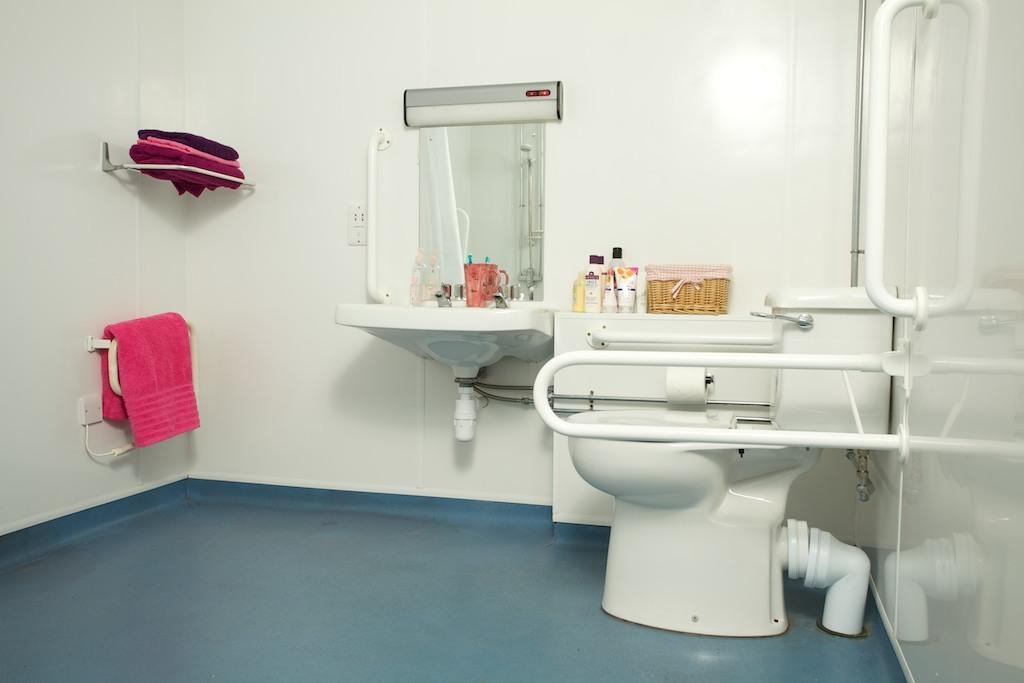Could you give a brief overview of what you see in this image? In the picture we can see a washroom with a toilet seat, beside it we can see a white color desk on it we can see some sanitize bottles and creams and beside it we can see a sink which is white in color and on it we can see a stand with brushed in it and to the wall we can see a mirror and beside it we can see a rack with clothes on it and under it we can see a hanger with towel which is pink in color and to the floor we can see a blue color mat. 